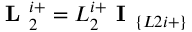<formula> <loc_0><loc_0><loc_500><loc_500>L _ { 2 } ^ { i + } = L _ { 2 } ^ { i + } I _ { \{ L 2 i + \} }</formula> 